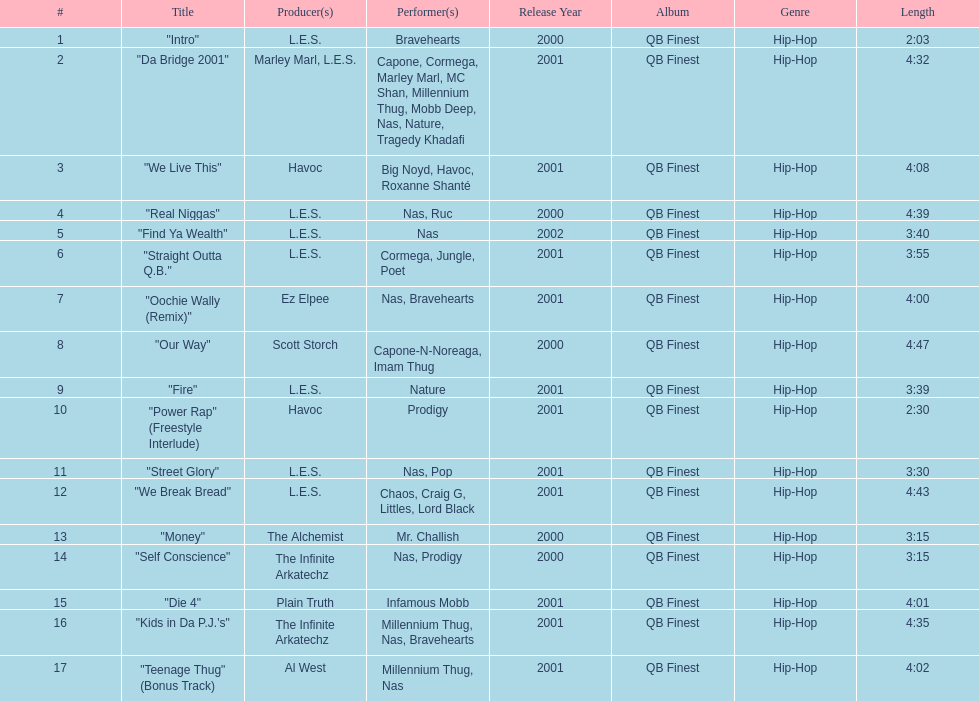After street glory, what song is listed? "We Break Bread". 